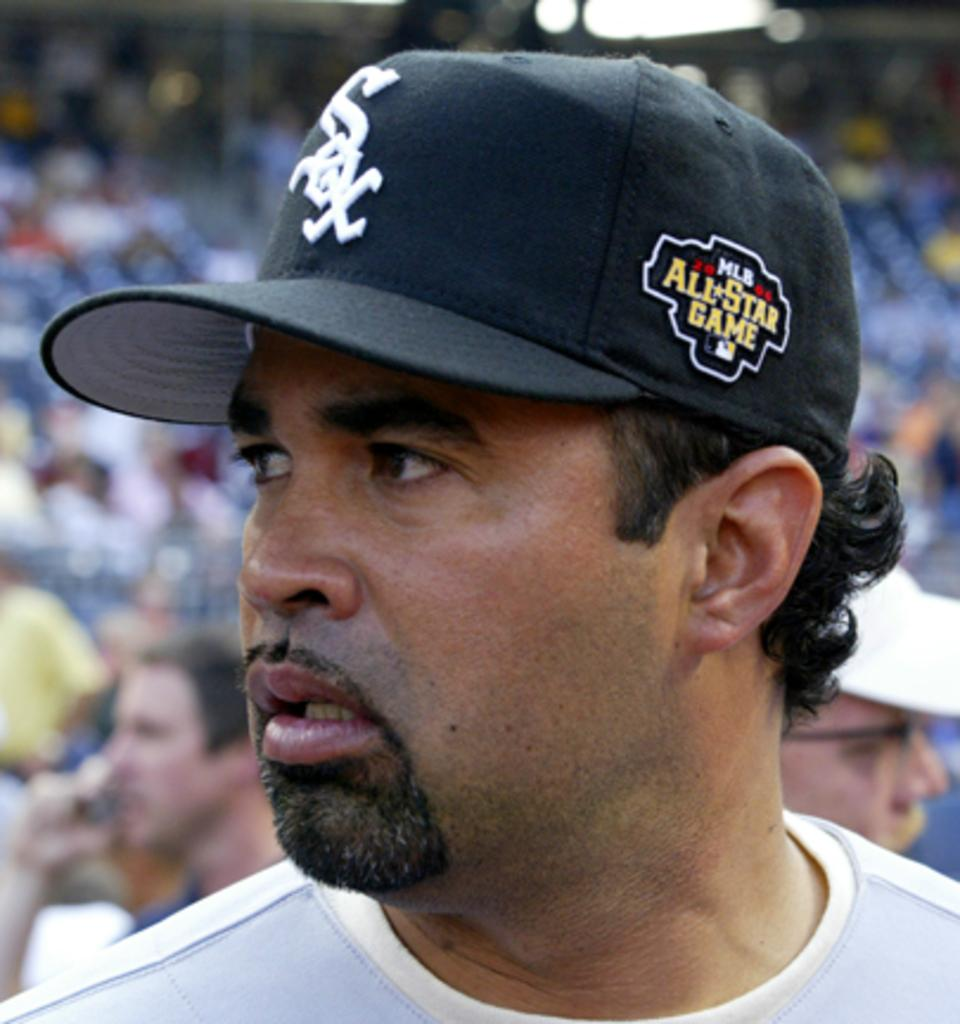<image>
Relay a brief, clear account of the picture shown. a man wearing an all star game hat on their head 